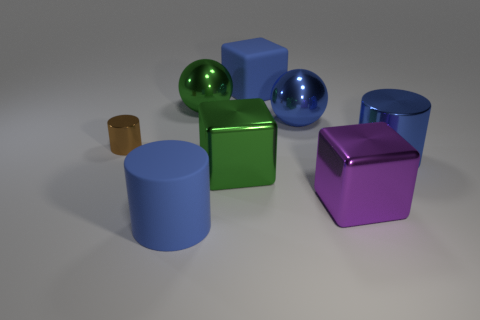There is a ball that is the same color as the large matte cylinder; what size is it?
Give a very brief answer. Large. Do the large blue matte object in front of the purple shiny cube and the blue metal thing that is in front of the small cylinder have the same shape?
Offer a very short reply. Yes. What number of metallic spheres are there?
Provide a succinct answer. 2. What shape is the small brown object that is the same material as the big purple object?
Give a very brief answer. Cylinder. Is there anything else of the same color as the big shiny cylinder?
Keep it short and to the point. Yes. Is the color of the rubber cylinder the same as the big matte thing behind the purple object?
Your answer should be compact. Yes. Is the number of big purple blocks to the left of the big purple thing less than the number of large blue spheres?
Give a very brief answer. Yes. What material is the cylinder that is in front of the purple metal block?
Your answer should be very brief. Rubber. How many other objects are there of the same size as the rubber block?
Provide a short and direct response. 6. Does the blue metallic cylinder have the same size as the metallic cube in front of the green metal block?
Offer a very short reply. Yes. 